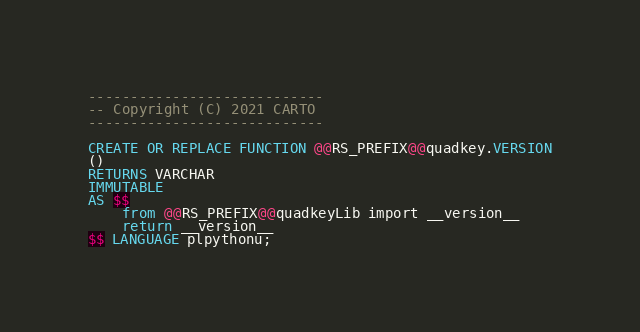<code> <loc_0><loc_0><loc_500><loc_500><_SQL_>----------------------------
-- Copyright (C) 2021 CARTO
----------------------------

CREATE OR REPLACE FUNCTION @@RS_PREFIX@@quadkey.VERSION
() 
RETURNS VARCHAR
IMMUTABLE
AS $$
    from @@RS_PREFIX@@quadkeyLib import __version__
    return __version__
$$ LANGUAGE plpythonu;</code> 